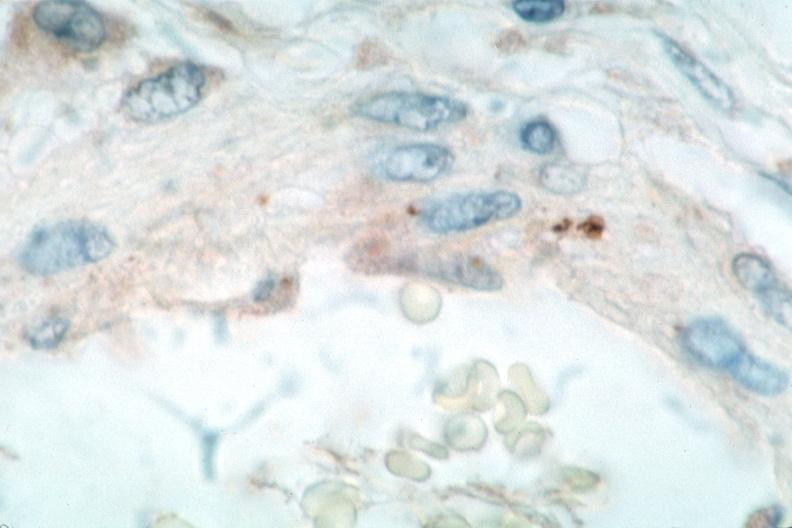does leiomyosarcoma show vasculitis?
Answer the question using a single word or phrase. No 